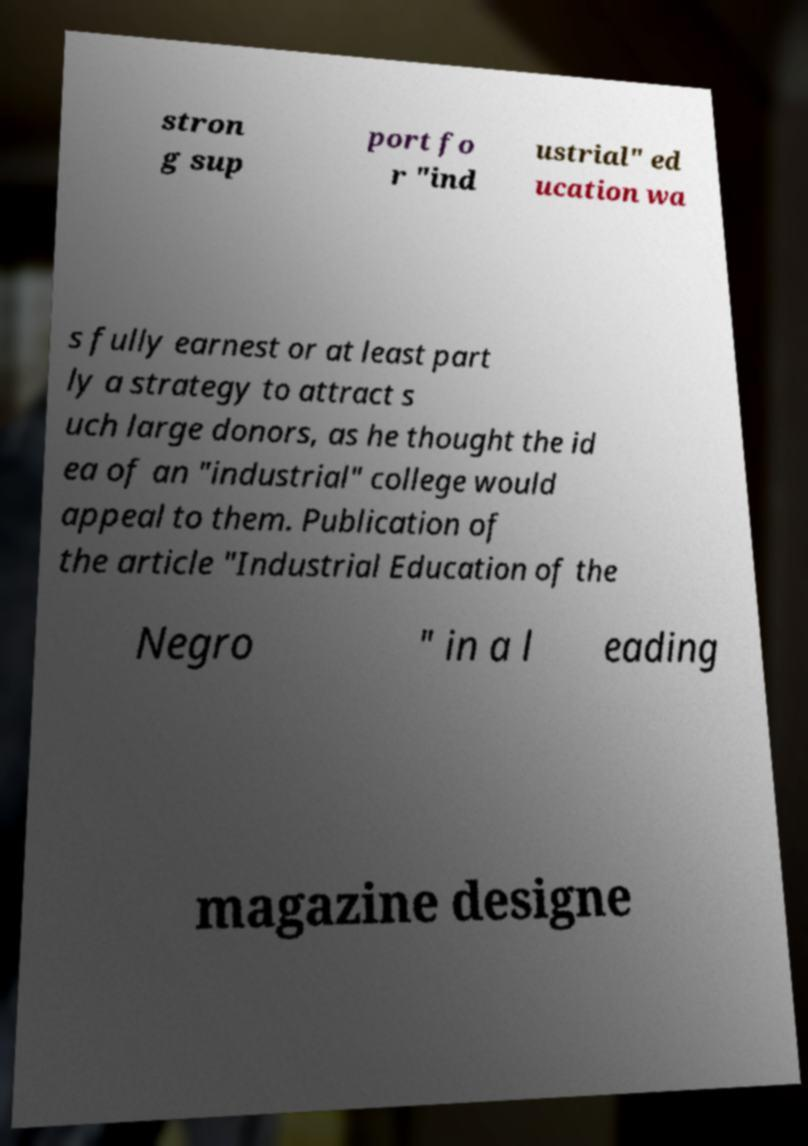Can you accurately transcribe the text from the provided image for me? stron g sup port fo r "ind ustrial" ed ucation wa s fully earnest or at least part ly a strategy to attract s uch large donors, as he thought the id ea of an "industrial" college would appeal to them. Publication of the article "Industrial Education of the Negro " in a l eading magazine designe 